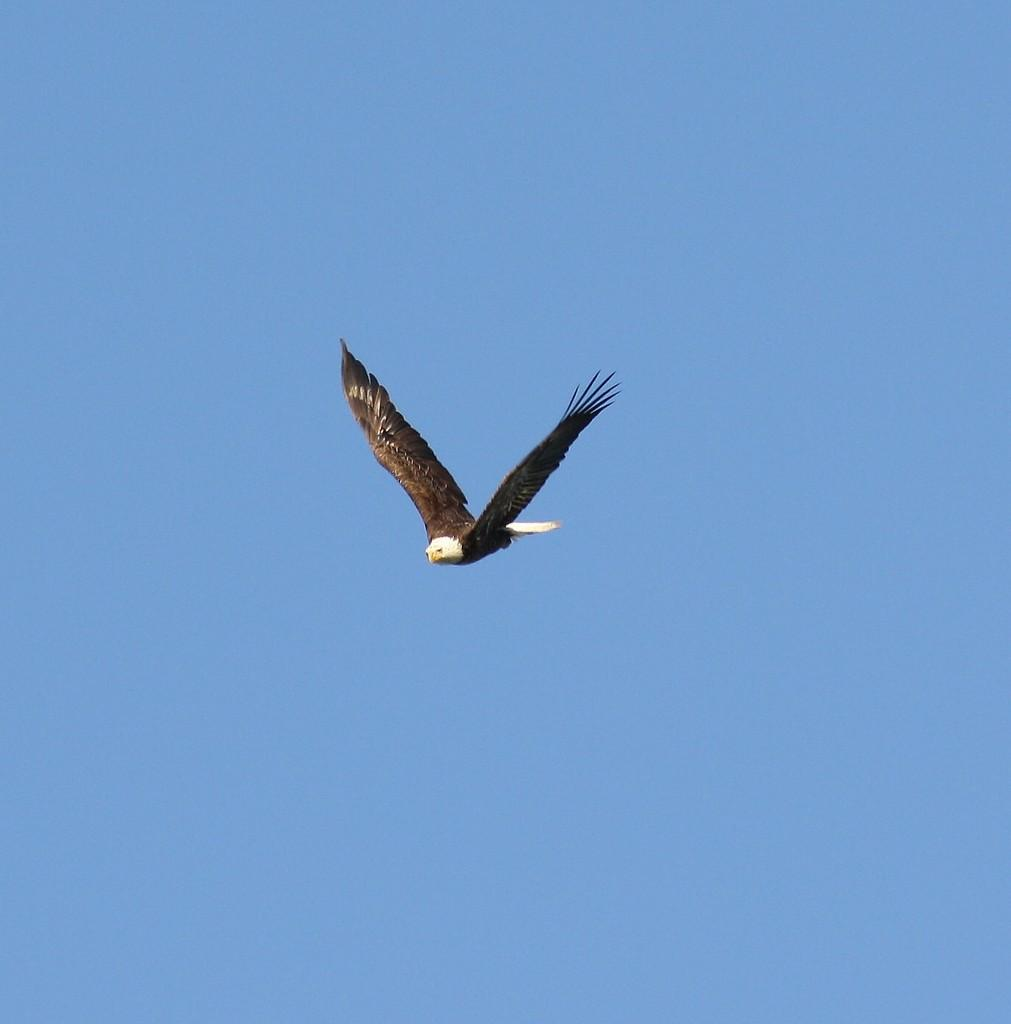What is the main subject of the image? The main subject of the image is a bird flying. Where is the bird located in the image? The bird is in the sky. What color is the background of the image? The background of the image is blue in color. What type of cub is visible in the image? There is no cub present in the image; it features a bird flying in the sky. What material is the leather made of in the image? There is no leather present in the image. 